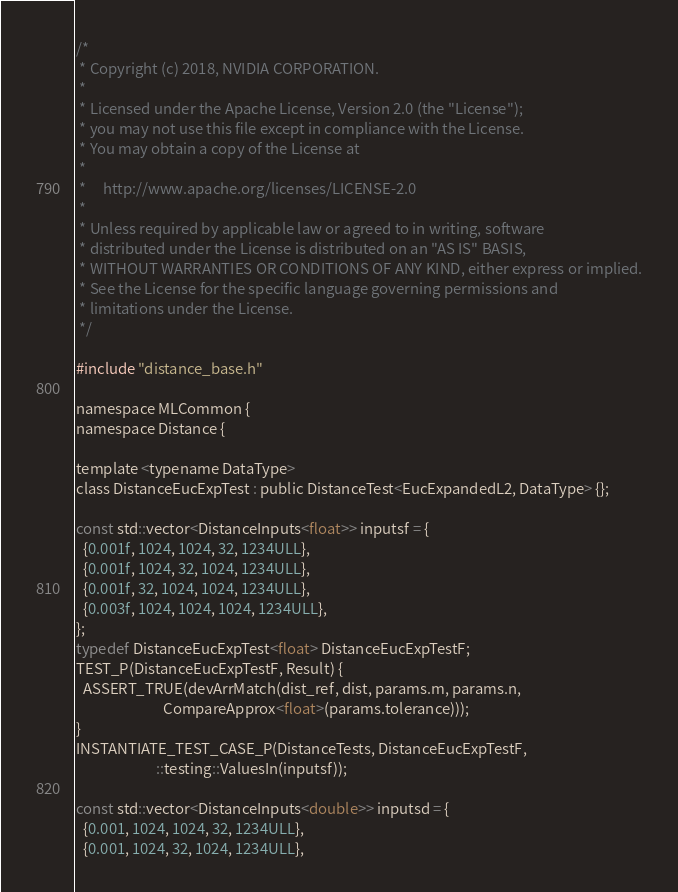<code> <loc_0><loc_0><loc_500><loc_500><_Cuda_>/*
 * Copyright (c) 2018, NVIDIA CORPORATION.
 *
 * Licensed under the Apache License, Version 2.0 (the "License");
 * you may not use this file except in compliance with the License.
 * You may obtain a copy of the License at
 *
 *     http://www.apache.org/licenses/LICENSE-2.0
 *
 * Unless required by applicable law or agreed to in writing, software
 * distributed under the License is distributed on an "AS IS" BASIS,
 * WITHOUT WARRANTIES OR CONDITIONS OF ANY KIND, either express or implied.
 * See the License for the specific language governing permissions and
 * limitations under the License.
 */

#include "distance_base.h"

namespace MLCommon {
namespace Distance {

template <typename DataType>
class DistanceEucExpTest : public DistanceTest<EucExpandedL2, DataType> {};

const std::vector<DistanceInputs<float>> inputsf = {
  {0.001f, 1024, 1024, 32, 1234ULL},
  {0.001f, 1024, 32, 1024, 1234ULL},
  {0.001f, 32, 1024, 1024, 1234ULL},
  {0.003f, 1024, 1024, 1024, 1234ULL},
};
typedef DistanceEucExpTest<float> DistanceEucExpTestF;
TEST_P(DistanceEucExpTestF, Result) {
  ASSERT_TRUE(devArrMatch(dist_ref, dist, params.m, params.n,
                          CompareApprox<float>(params.tolerance)));
}
INSTANTIATE_TEST_CASE_P(DistanceTests, DistanceEucExpTestF,
                        ::testing::ValuesIn(inputsf));

const std::vector<DistanceInputs<double>> inputsd = {
  {0.001, 1024, 1024, 32, 1234ULL},
  {0.001, 1024, 32, 1024, 1234ULL},</code> 